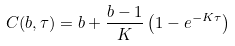Convert formula to latex. <formula><loc_0><loc_0><loc_500><loc_500>C ( b , \tau ) = b + \frac { b - 1 } { K } \left ( 1 - e ^ { - K \tau } \right )</formula> 